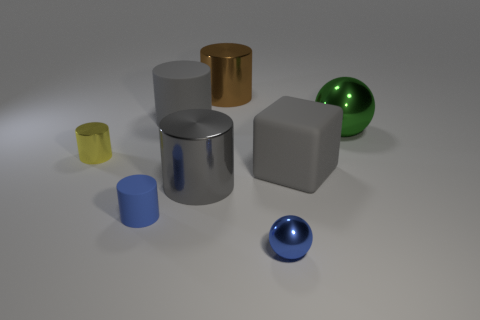Subtract all gray cylinders. How many cylinders are left? 3 Subtract all gray cubes. How many gray cylinders are left? 2 Subtract all yellow cylinders. How many cylinders are left? 4 Add 1 big brown metallic cylinders. How many objects exist? 9 Subtract all blocks. How many objects are left? 7 Subtract 0 red blocks. How many objects are left? 8 Subtract 1 spheres. How many spheres are left? 1 Subtract all brown cylinders. Subtract all green balls. How many cylinders are left? 4 Subtract all matte blocks. Subtract all yellow metal objects. How many objects are left? 6 Add 2 yellow cylinders. How many yellow cylinders are left? 3 